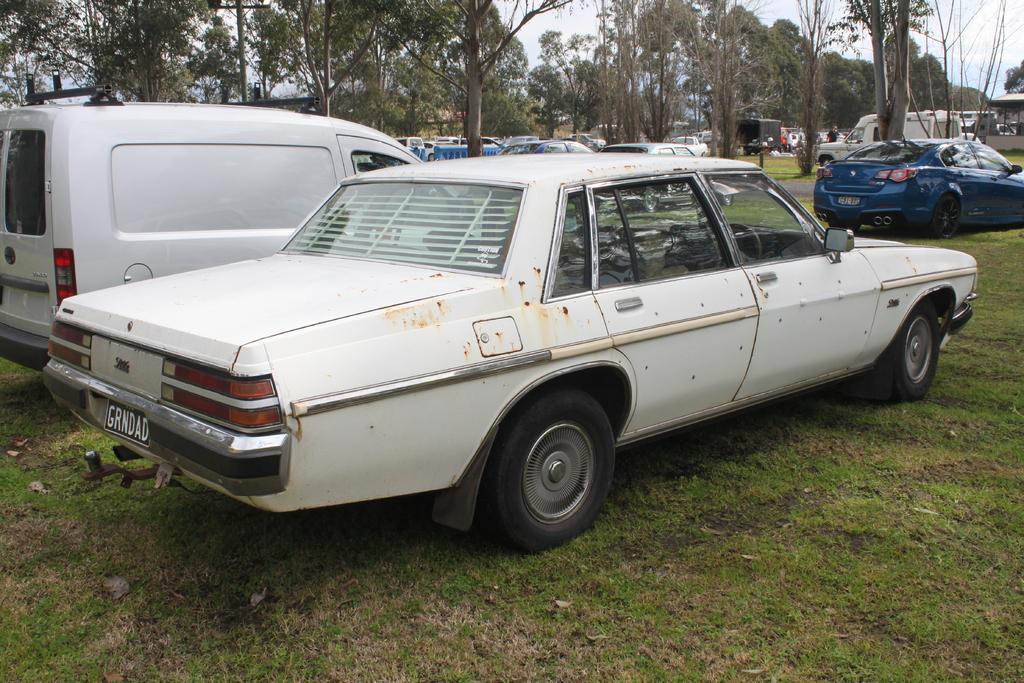Describe this image in one or two sentences. This image consists of many cars parked on the ground. At the bottom, there is green grass. In the background, there are trees. At the top, there is sky. 